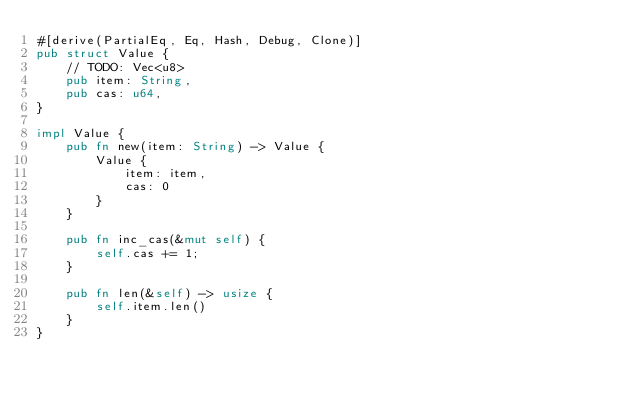<code> <loc_0><loc_0><loc_500><loc_500><_Rust_>#[derive(PartialEq, Eq, Hash, Debug, Clone)]
pub struct Value {
    // TODO: Vec<u8>
    pub item: String,
    pub cas: u64,
}

impl Value {
    pub fn new(item: String) -> Value {
        Value { 
            item: item, 
            cas: 0 
        }
    }

    pub fn inc_cas(&mut self) {
        self.cas += 1;
    }

    pub fn len(&self) -> usize {
        self.item.len()
    }
}</code> 